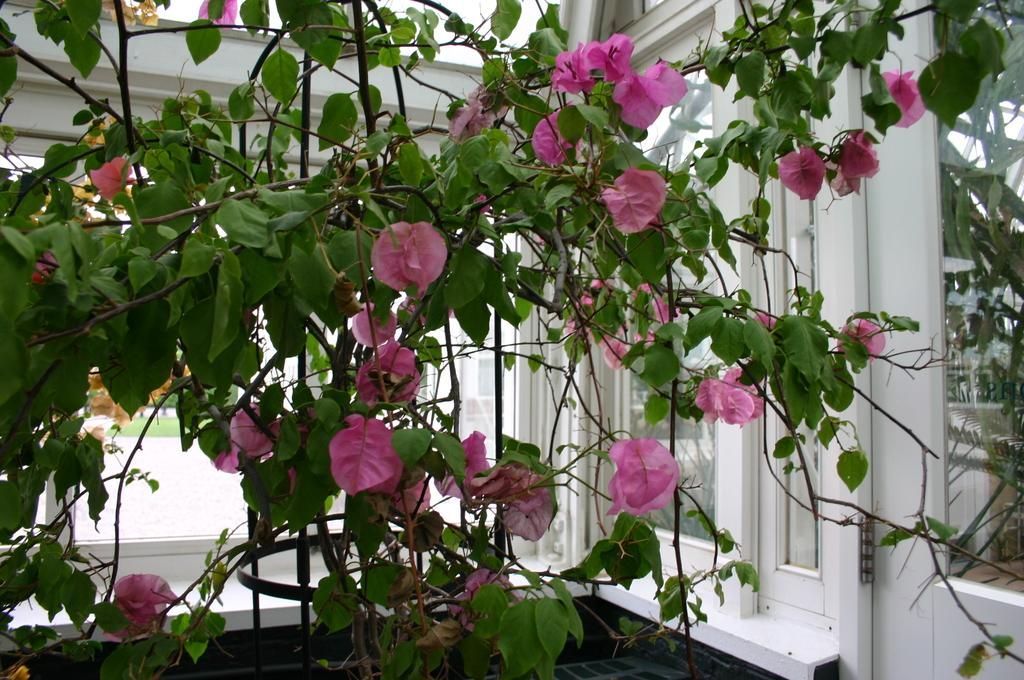What type of plant is in the picture? There is a plant in the picture, and it has flowers. What can be seen in the background of the picture? There is a door and a window in the background of the picture. What type of pen is visible on the plant in the image? There is no pen present on the plant in the image; it only features a plant with flowers. 